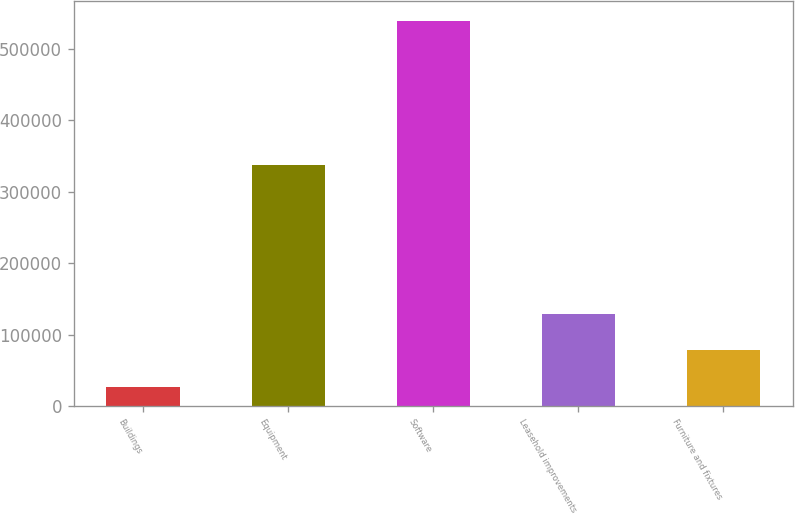Convert chart. <chart><loc_0><loc_0><loc_500><loc_500><bar_chart><fcel>Buildings<fcel>Equipment<fcel>Software<fcel>Leasehold improvements<fcel>Furniture and fixtures<nl><fcel>27179<fcel>337589<fcel>539879<fcel>129719<fcel>78449<nl></chart> 